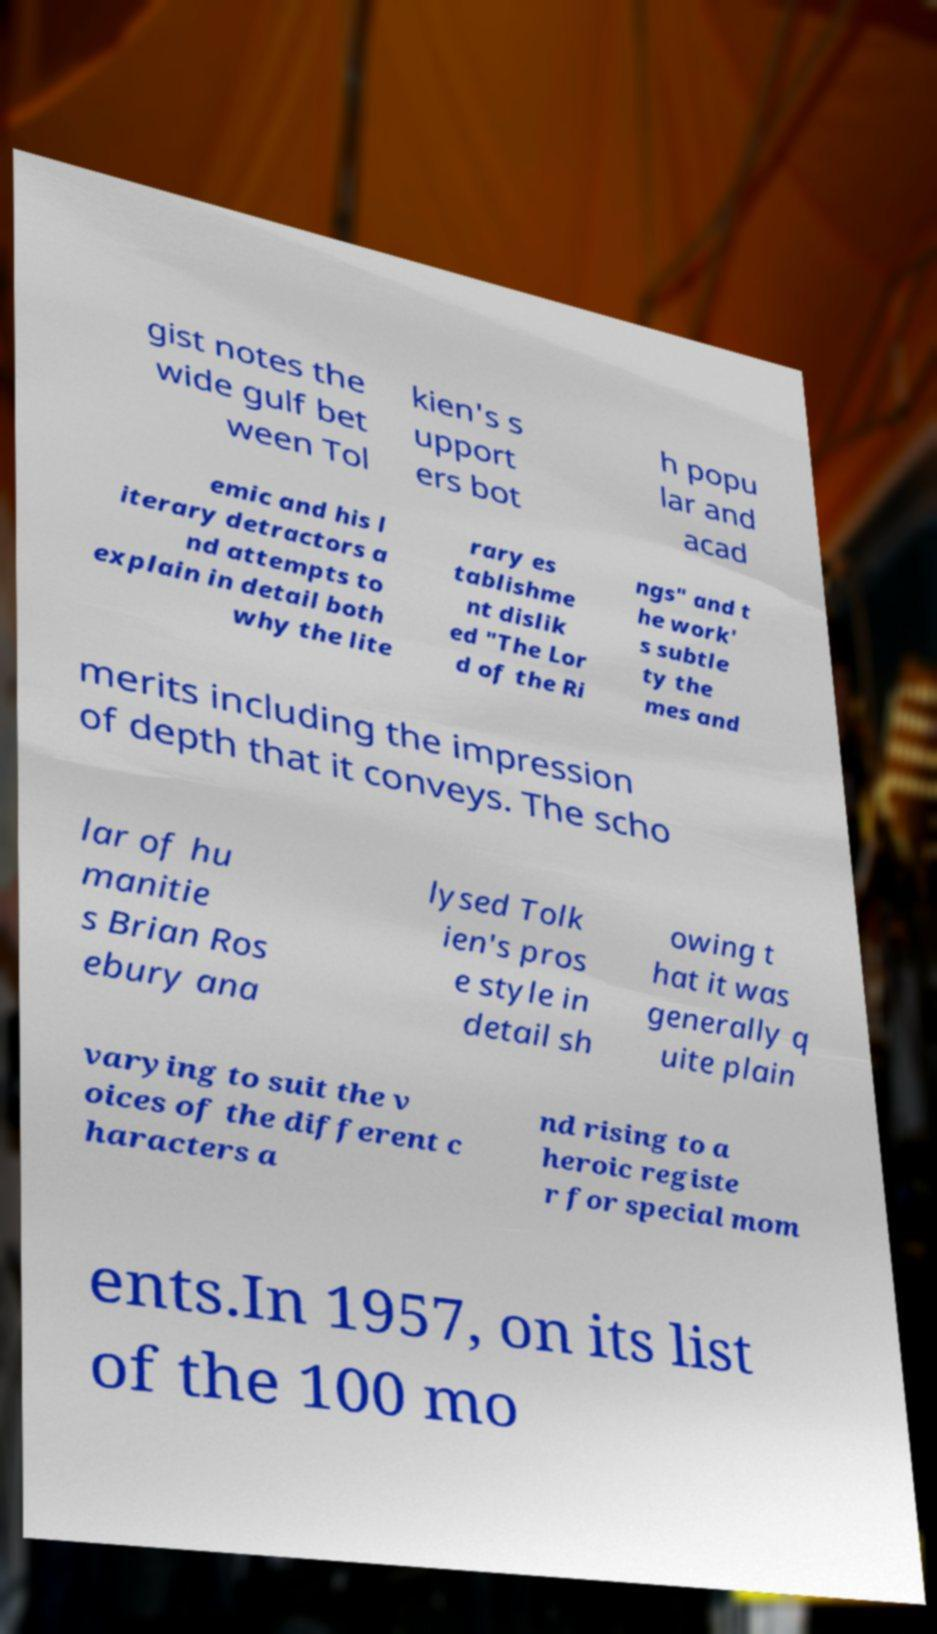I need the written content from this picture converted into text. Can you do that? gist notes the wide gulf bet ween Tol kien's s upport ers bot h popu lar and acad emic and his l iterary detractors a nd attempts to explain in detail both why the lite rary es tablishme nt dislik ed "The Lor d of the Ri ngs" and t he work' s subtle ty the mes and merits including the impression of depth that it conveys. The scho lar of hu manitie s Brian Ros ebury ana lysed Tolk ien's pros e style in detail sh owing t hat it was generally q uite plain varying to suit the v oices of the different c haracters a nd rising to a heroic registe r for special mom ents.In 1957, on its list of the 100 mo 